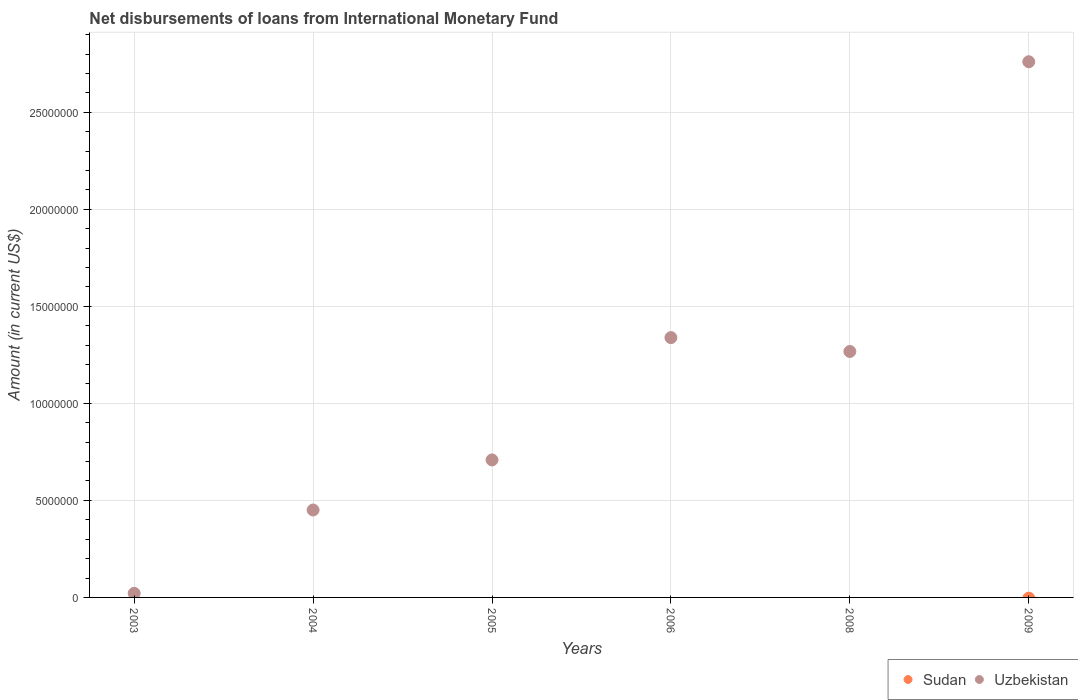Is the number of dotlines equal to the number of legend labels?
Give a very brief answer. No. Across all years, what is the maximum amount of loans disbursed in Uzbekistan?
Keep it short and to the point. 2.76e+07. What is the total amount of loans disbursed in Uzbekistan in the graph?
Offer a terse response. 6.55e+07. What is the difference between the amount of loans disbursed in Uzbekistan in 2004 and that in 2006?
Provide a succinct answer. -8.88e+06. What is the difference between the amount of loans disbursed in Sudan in 2005 and the amount of loans disbursed in Uzbekistan in 2009?
Provide a succinct answer. -2.76e+07. What is the average amount of loans disbursed in Sudan per year?
Offer a terse response. 0. What is the ratio of the amount of loans disbursed in Uzbekistan in 2004 to that in 2006?
Offer a terse response. 0.34. What is the difference between the highest and the second highest amount of loans disbursed in Uzbekistan?
Offer a terse response. 1.42e+07. What is the difference between the highest and the lowest amount of loans disbursed in Uzbekistan?
Your response must be concise. 2.74e+07. In how many years, is the amount of loans disbursed in Uzbekistan greater than the average amount of loans disbursed in Uzbekistan taken over all years?
Keep it short and to the point. 3. Is the sum of the amount of loans disbursed in Uzbekistan in 2003 and 2004 greater than the maximum amount of loans disbursed in Sudan across all years?
Keep it short and to the point. Yes. Is the amount of loans disbursed in Sudan strictly greater than the amount of loans disbursed in Uzbekistan over the years?
Your answer should be compact. No. Is the amount of loans disbursed in Sudan strictly less than the amount of loans disbursed in Uzbekistan over the years?
Offer a terse response. Yes. How many dotlines are there?
Offer a terse response. 1. What is the difference between two consecutive major ticks on the Y-axis?
Your response must be concise. 5.00e+06. Are the values on the major ticks of Y-axis written in scientific E-notation?
Make the answer very short. No. How are the legend labels stacked?
Make the answer very short. Horizontal. What is the title of the graph?
Offer a terse response. Net disbursements of loans from International Monetary Fund. Does "Kuwait" appear as one of the legend labels in the graph?
Provide a succinct answer. No. What is the label or title of the X-axis?
Your response must be concise. Years. What is the label or title of the Y-axis?
Provide a short and direct response. Amount (in current US$). What is the Amount (in current US$) of Sudan in 2004?
Your answer should be very brief. 0. What is the Amount (in current US$) of Uzbekistan in 2004?
Your response must be concise. 4.50e+06. What is the Amount (in current US$) in Uzbekistan in 2005?
Your answer should be compact. 7.08e+06. What is the Amount (in current US$) of Uzbekistan in 2006?
Offer a very short reply. 1.34e+07. What is the Amount (in current US$) of Sudan in 2008?
Your answer should be compact. 0. What is the Amount (in current US$) in Uzbekistan in 2008?
Give a very brief answer. 1.27e+07. What is the Amount (in current US$) of Sudan in 2009?
Keep it short and to the point. 0. What is the Amount (in current US$) in Uzbekistan in 2009?
Ensure brevity in your answer.  2.76e+07. Across all years, what is the maximum Amount (in current US$) in Uzbekistan?
Offer a very short reply. 2.76e+07. What is the total Amount (in current US$) of Uzbekistan in the graph?
Give a very brief answer. 6.55e+07. What is the difference between the Amount (in current US$) in Uzbekistan in 2003 and that in 2004?
Give a very brief answer. -4.30e+06. What is the difference between the Amount (in current US$) in Uzbekistan in 2003 and that in 2005?
Provide a succinct answer. -6.88e+06. What is the difference between the Amount (in current US$) in Uzbekistan in 2003 and that in 2006?
Provide a short and direct response. -1.32e+07. What is the difference between the Amount (in current US$) of Uzbekistan in 2003 and that in 2008?
Give a very brief answer. -1.25e+07. What is the difference between the Amount (in current US$) in Uzbekistan in 2003 and that in 2009?
Offer a very short reply. -2.74e+07. What is the difference between the Amount (in current US$) of Uzbekistan in 2004 and that in 2005?
Keep it short and to the point. -2.58e+06. What is the difference between the Amount (in current US$) of Uzbekistan in 2004 and that in 2006?
Keep it short and to the point. -8.88e+06. What is the difference between the Amount (in current US$) of Uzbekistan in 2004 and that in 2008?
Offer a very short reply. -8.17e+06. What is the difference between the Amount (in current US$) in Uzbekistan in 2004 and that in 2009?
Offer a very short reply. -2.31e+07. What is the difference between the Amount (in current US$) of Uzbekistan in 2005 and that in 2006?
Your answer should be very brief. -6.30e+06. What is the difference between the Amount (in current US$) of Uzbekistan in 2005 and that in 2008?
Provide a succinct answer. -5.59e+06. What is the difference between the Amount (in current US$) of Uzbekistan in 2005 and that in 2009?
Provide a succinct answer. -2.05e+07. What is the difference between the Amount (in current US$) of Uzbekistan in 2006 and that in 2008?
Your answer should be very brief. 7.15e+05. What is the difference between the Amount (in current US$) of Uzbekistan in 2006 and that in 2009?
Provide a succinct answer. -1.42e+07. What is the difference between the Amount (in current US$) in Uzbekistan in 2008 and that in 2009?
Offer a very short reply. -1.49e+07. What is the average Amount (in current US$) in Uzbekistan per year?
Offer a very short reply. 1.09e+07. What is the ratio of the Amount (in current US$) in Uzbekistan in 2003 to that in 2004?
Ensure brevity in your answer.  0.05. What is the ratio of the Amount (in current US$) of Uzbekistan in 2003 to that in 2005?
Offer a very short reply. 0.03. What is the ratio of the Amount (in current US$) of Uzbekistan in 2003 to that in 2006?
Offer a very short reply. 0.02. What is the ratio of the Amount (in current US$) in Uzbekistan in 2003 to that in 2008?
Your answer should be very brief. 0.02. What is the ratio of the Amount (in current US$) in Uzbekistan in 2003 to that in 2009?
Provide a succinct answer. 0.01. What is the ratio of the Amount (in current US$) in Uzbekistan in 2004 to that in 2005?
Ensure brevity in your answer.  0.64. What is the ratio of the Amount (in current US$) of Uzbekistan in 2004 to that in 2006?
Your answer should be very brief. 0.34. What is the ratio of the Amount (in current US$) in Uzbekistan in 2004 to that in 2008?
Give a very brief answer. 0.36. What is the ratio of the Amount (in current US$) in Uzbekistan in 2004 to that in 2009?
Your answer should be very brief. 0.16. What is the ratio of the Amount (in current US$) of Uzbekistan in 2005 to that in 2006?
Your response must be concise. 0.53. What is the ratio of the Amount (in current US$) in Uzbekistan in 2005 to that in 2008?
Your answer should be very brief. 0.56. What is the ratio of the Amount (in current US$) in Uzbekistan in 2005 to that in 2009?
Your response must be concise. 0.26. What is the ratio of the Amount (in current US$) of Uzbekistan in 2006 to that in 2008?
Provide a succinct answer. 1.06. What is the ratio of the Amount (in current US$) in Uzbekistan in 2006 to that in 2009?
Provide a succinct answer. 0.48. What is the ratio of the Amount (in current US$) in Uzbekistan in 2008 to that in 2009?
Your response must be concise. 0.46. What is the difference between the highest and the second highest Amount (in current US$) of Uzbekistan?
Offer a very short reply. 1.42e+07. What is the difference between the highest and the lowest Amount (in current US$) in Uzbekistan?
Keep it short and to the point. 2.74e+07. 